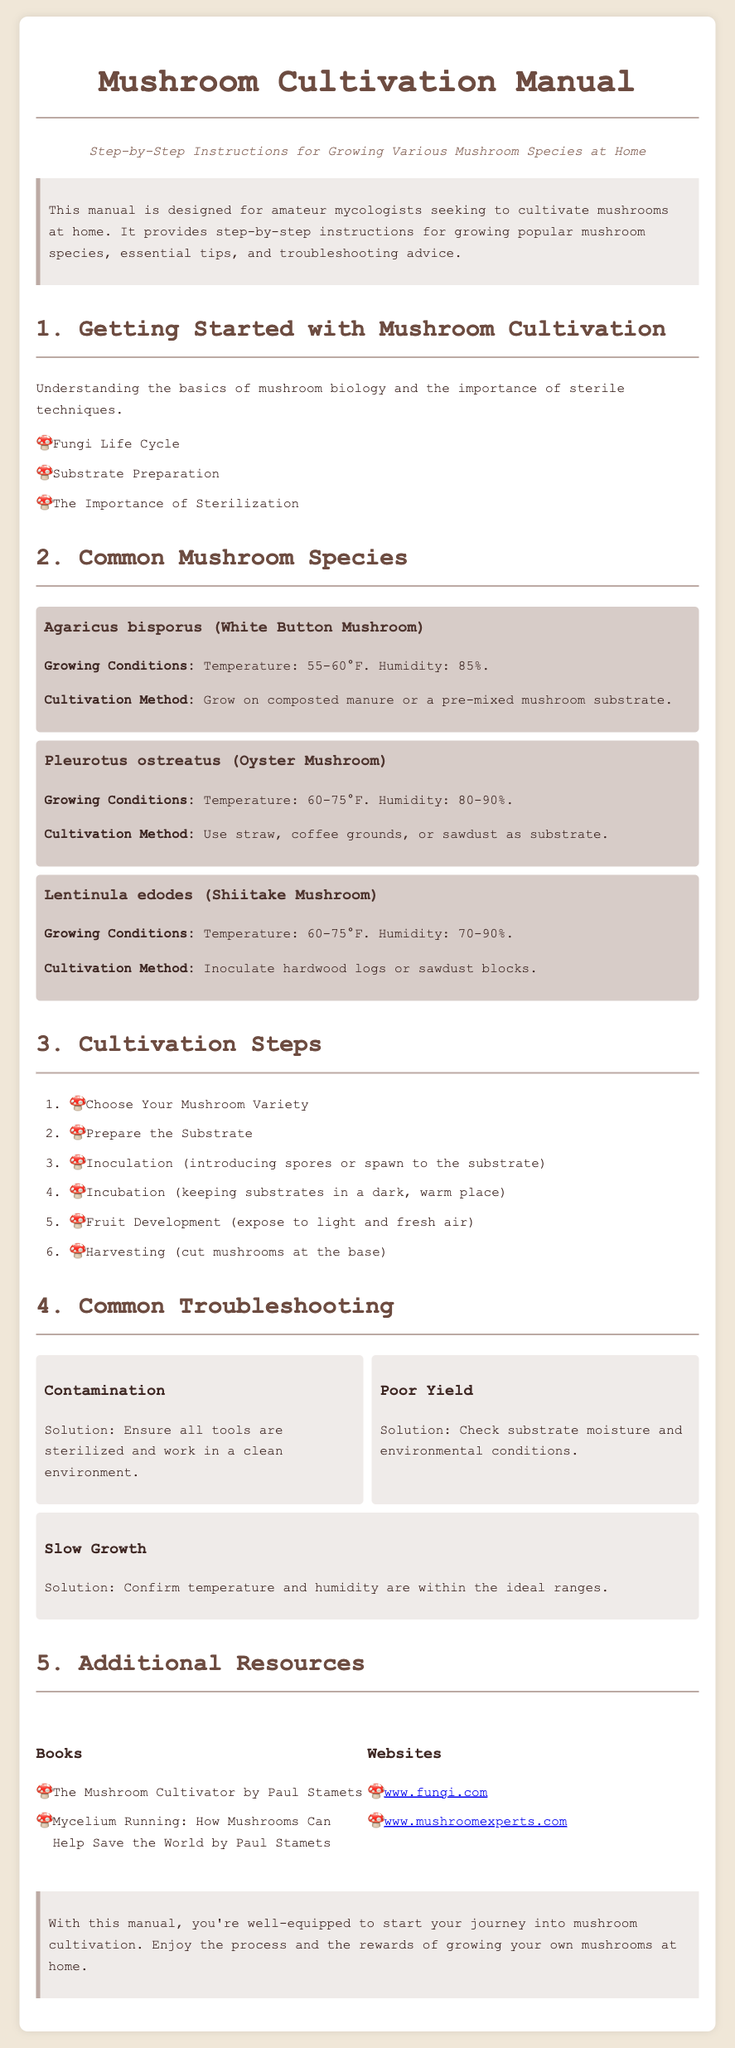What is the title of the manual? The title is found in the header of the document, which is "Mushroom Cultivation Manual."
Answer: Mushroom Cultivation Manual What is the growing condition temperature for Oyster Mushrooms? The growing conditions for Oyster Mushrooms are specified under their section, which states a temperature of 60-75°F.
Answer: 60-75°F How many steps are there in the cultivation process? The number of steps in the cultivation process is mentioned in the section "Cultivation Steps," which lists six steps.
Answer: 6 What substrate is recommended for growing White Button Mushrooms? The recommended substrate for White Button Mushrooms is detailed in their section, which mentions composted manure or a pre-mixed mushroom substrate.
Answer: composted manure or pre-mixed mushroom substrate What solution is suggested for contamination issues? The suggested solution for contamination issues is found in the troubleshooting section, indicating to ensure all tools are sterilized and work in a clean environment.
Answer: Ensure all tools are sterilized and work in a clean environment What is the maximum humidity range for Shiitake Mushrooms? The maximum humidity range for Shiitake Mushrooms is stated in their growing conditions section, which is 90%.
Answer: 90% How many websites are listed in the additional resources section? The additional resources section contains two websites, as indicated in the list under that heading.
Answer: 2 Who is the author of "The Mushroom Cultivator"? The book cited in the resources section is by Paul Stamets, as mentioned in the listing.
Answer: Paul Stamets 